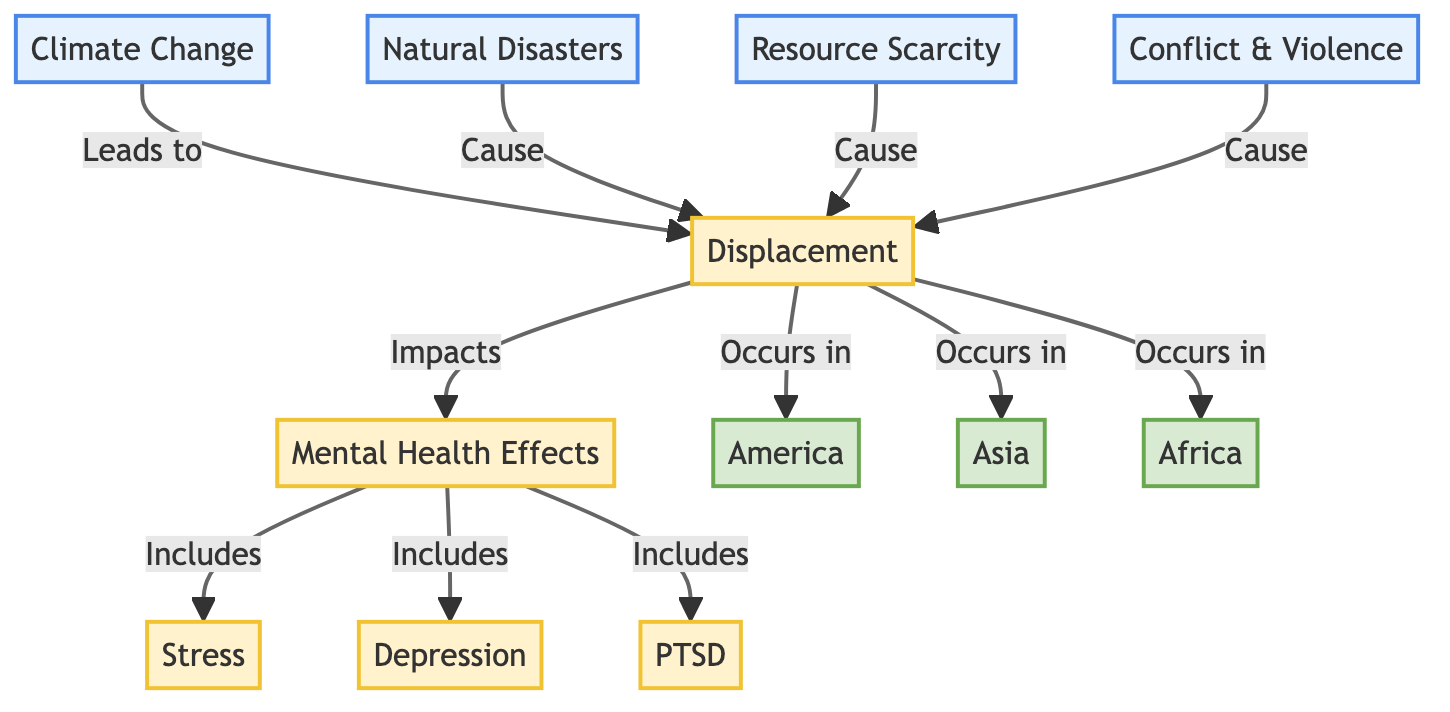What's the primary cause of displacement in the diagram? The flowchart shows that displacement is primarily caused by climate change, which leads to various triggering factors such as natural disasters, resource scarcity, and conflict. The initial node indicates that climate change is at the top of the causal chain for displacement.
Answer: Climate Change How many regions are impacted by displacement in this diagram? The diagram lists three specific regions where displacement occurs: America, Asia, and Africa. These regions are connected to the displacement node, showing their involvement in these processes.
Answer: Three What are the main mental health effects listed in the diagram? The mental health effects include three specific issues: stress, depression, and PTSD. The diagram clearly outlines these as components of the broader mental health effects stemming from displacement.
Answer: Stress, Depression, PTSD How do natural disasters relate to displacement? According to the diagram, natural disasters are identified as one of the causes of displacement. The flowchart directly links the natural disasters node to the displacement node, establishing a causal connection that explains how disasters can lead to forced migration.
Answer: Cause Which region is associated with conflict and violence related to displacement? The diagram indicates that conflict and violence are causal factors for displacement but does not specify a region explicitly linked to this effect. However, since conflict is a general cause, it applies across the regions of America, Asia, and Africa. The question infers this implicit connection.
Answer: All Regions (implicitly) What is the connection between resource scarcity and mental health effects? Resource scarcity leads to displacement, which subsequently impacts mental health. The diagram illustrates that while there is no direct link from resource scarcity to mental health effects, the intermediate step is displacement, which connects these two aspects.
Answer: Indirect (via displacement) 